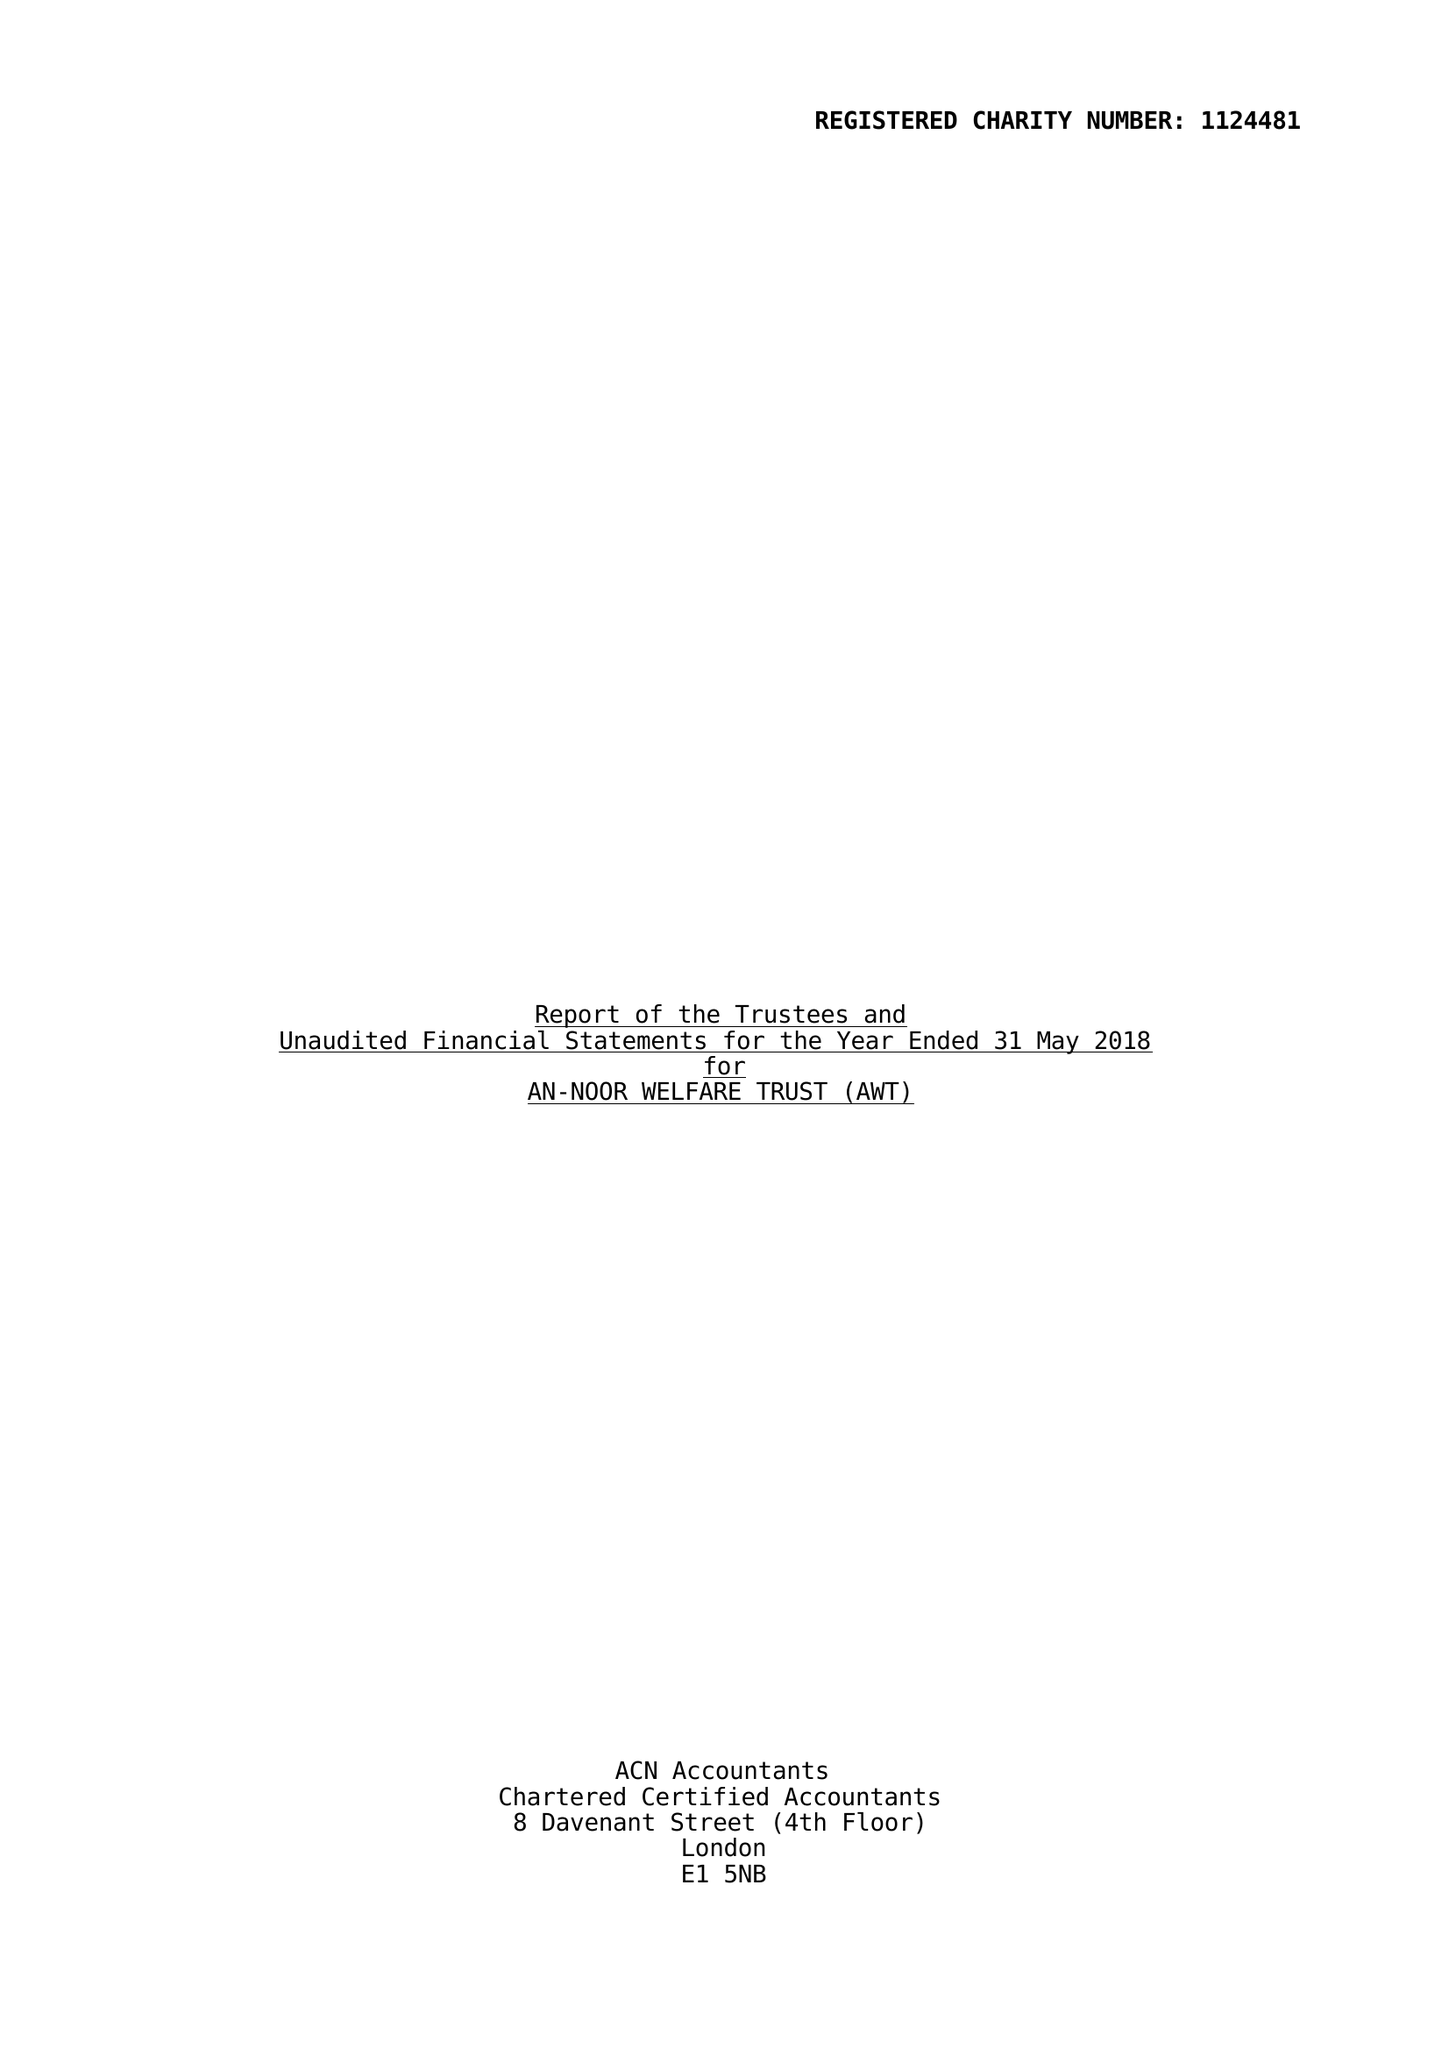What is the value for the address__postcode?
Answer the question using a single word or phrase. SE15 5HZ 